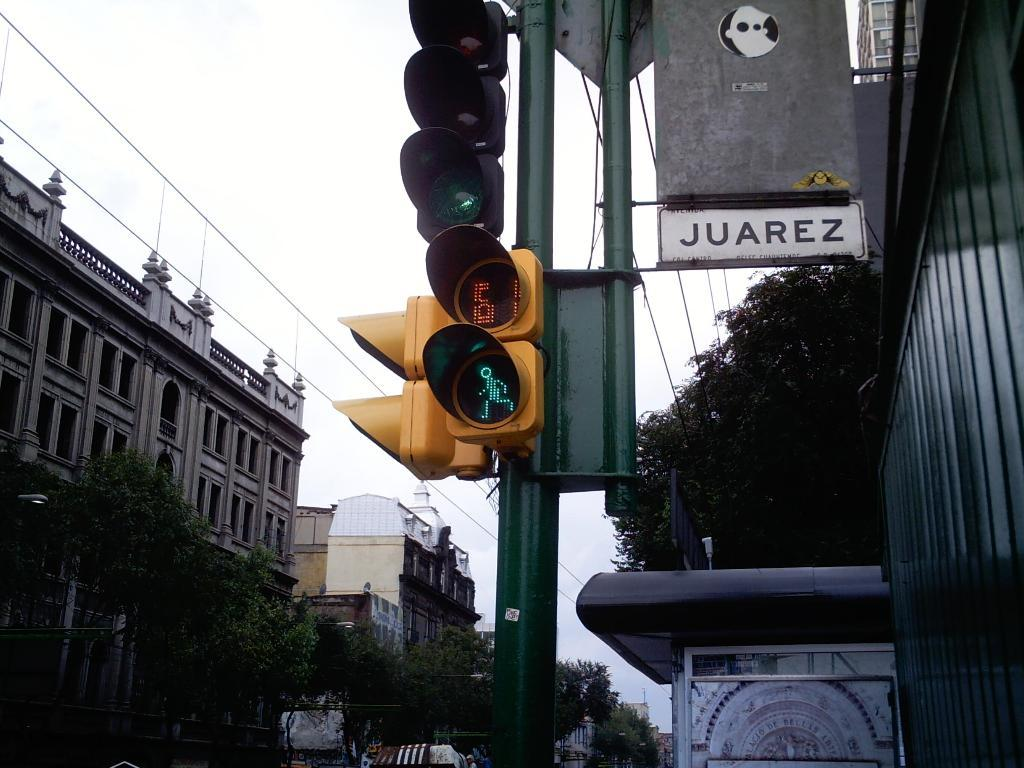Provide a one-sentence caption for the provided image. Juarez has crosswalks that give people time to pass. 